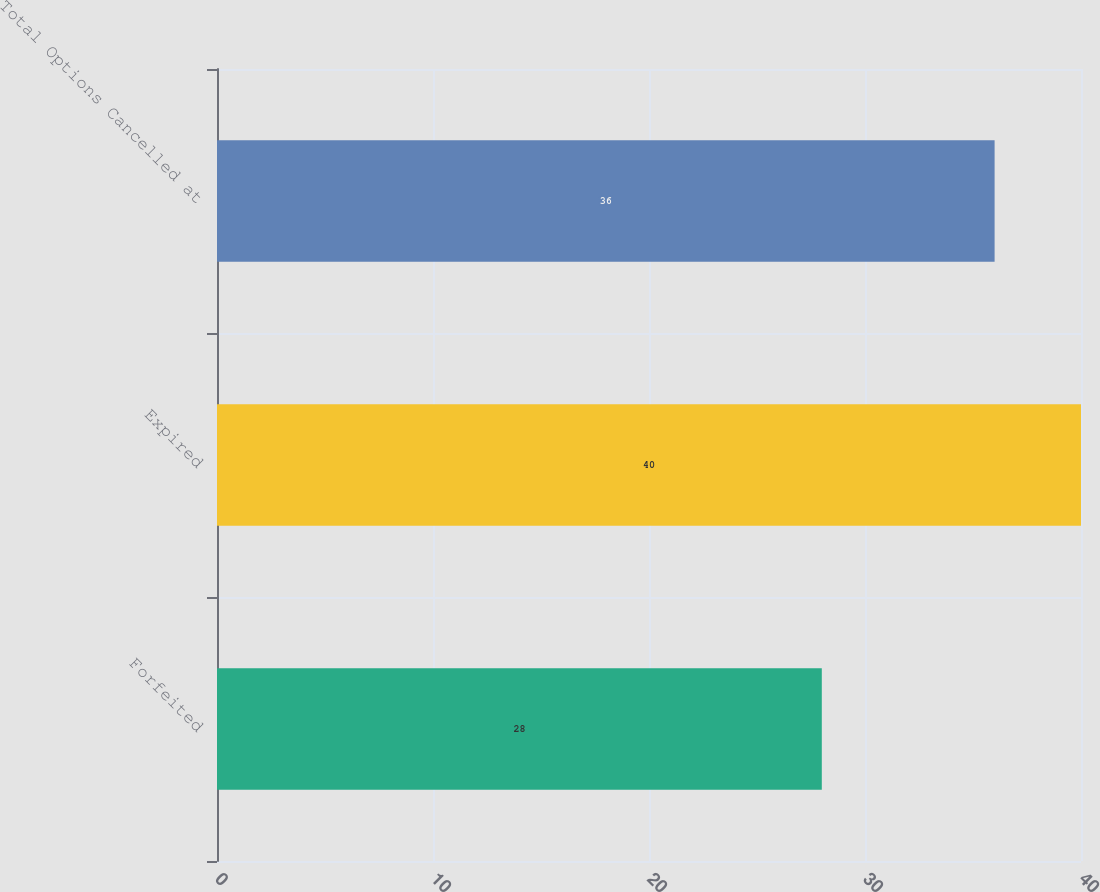Convert chart. <chart><loc_0><loc_0><loc_500><loc_500><bar_chart><fcel>Forfeited<fcel>Expired<fcel>Total Options Cancelled at<nl><fcel>28<fcel>40<fcel>36<nl></chart> 